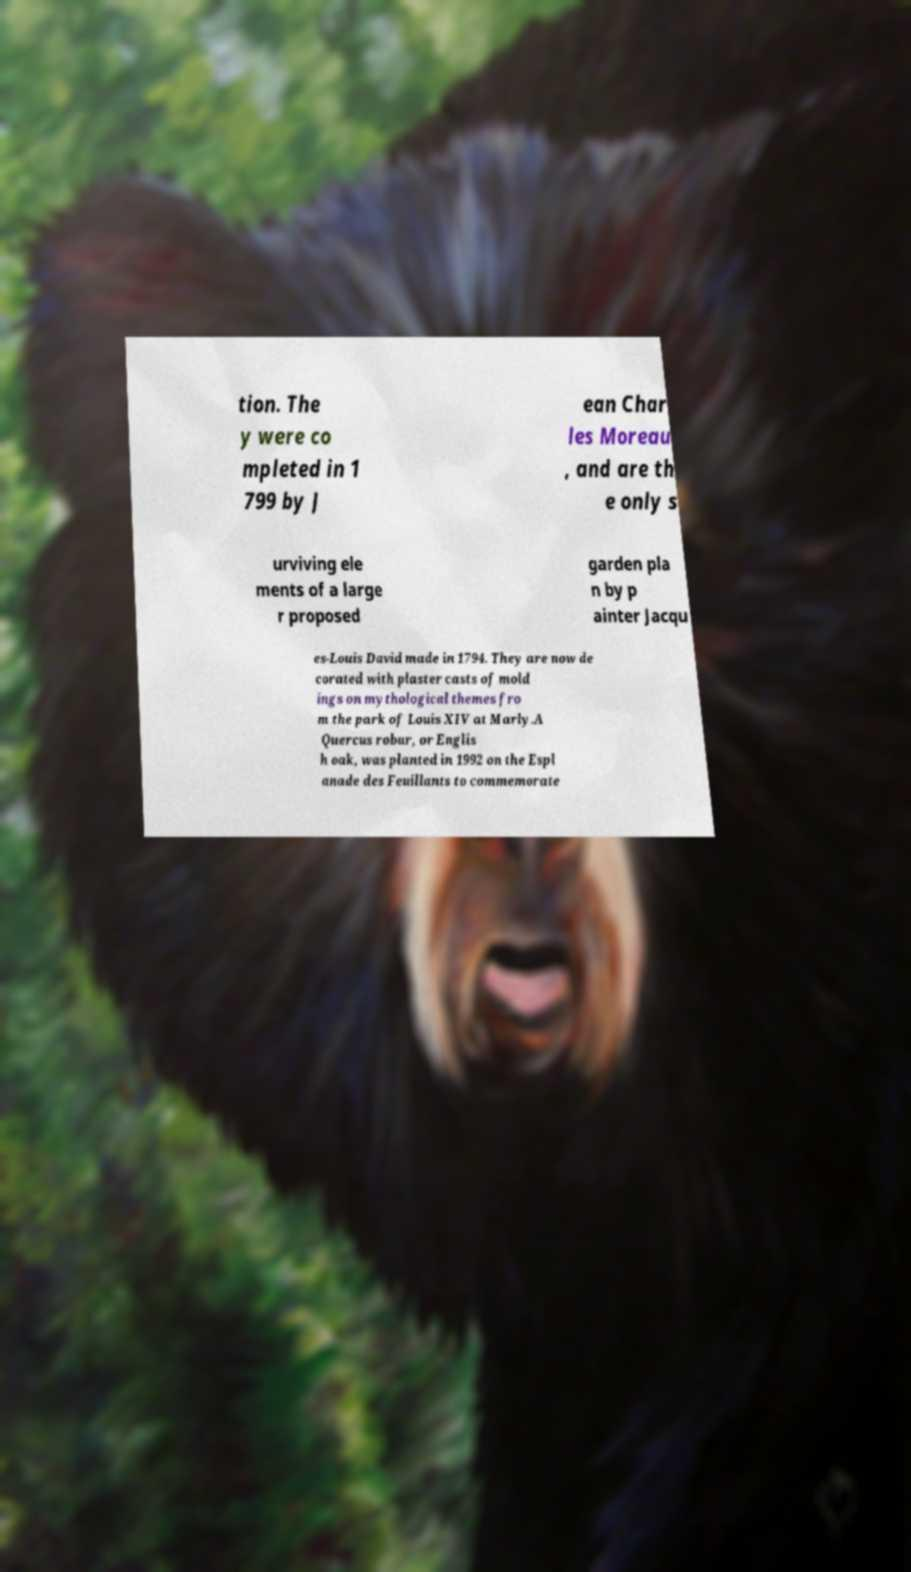What messages or text are displayed in this image? I need them in a readable, typed format. tion. The y were co mpleted in 1 799 by J ean Char les Moreau , and are th e only s urviving ele ments of a large r proposed garden pla n by p ainter Jacqu es-Louis David made in 1794. They are now de corated with plaster casts of mold ings on mythological themes fro m the park of Louis XIV at Marly.A Quercus robur, or Englis h oak, was planted in 1992 on the Espl anade des Feuillants to commemorate 